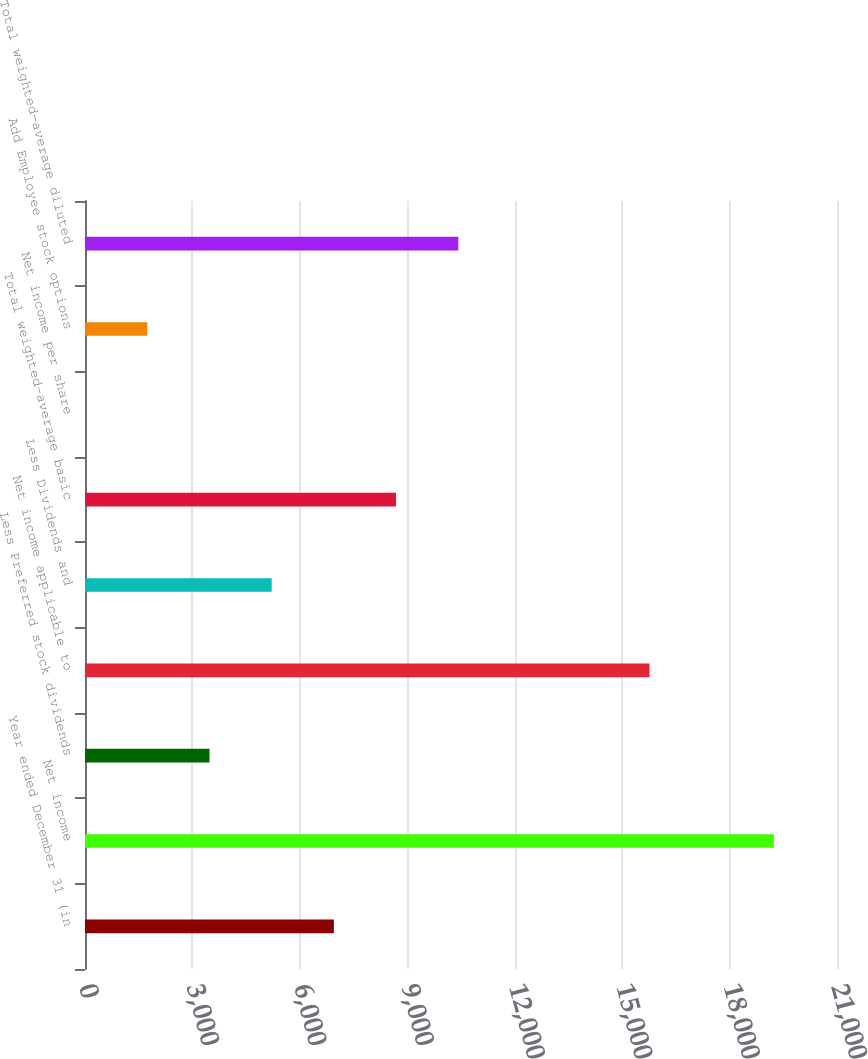Convert chart. <chart><loc_0><loc_0><loc_500><loc_500><bar_chart><fcel>Year ended December 31 (in<fcel>Net income<fcel>Less Preferred stock dividends<fcel>Net income applicable to<fcel>Less Dividends and<fcel>Total weighted-average basic<fcel>Net income per share<fcel>Add Employee stock options<fcel>Total weighted-average diluted<nl><fcel>6950.38<fcel>19237.2<fcel>3477.18<fcel>15764<fcel>5213.78<fcel>8686.98<fcel>3.98<fcel>1740.58<fcel>10423.6<nl></chart> 